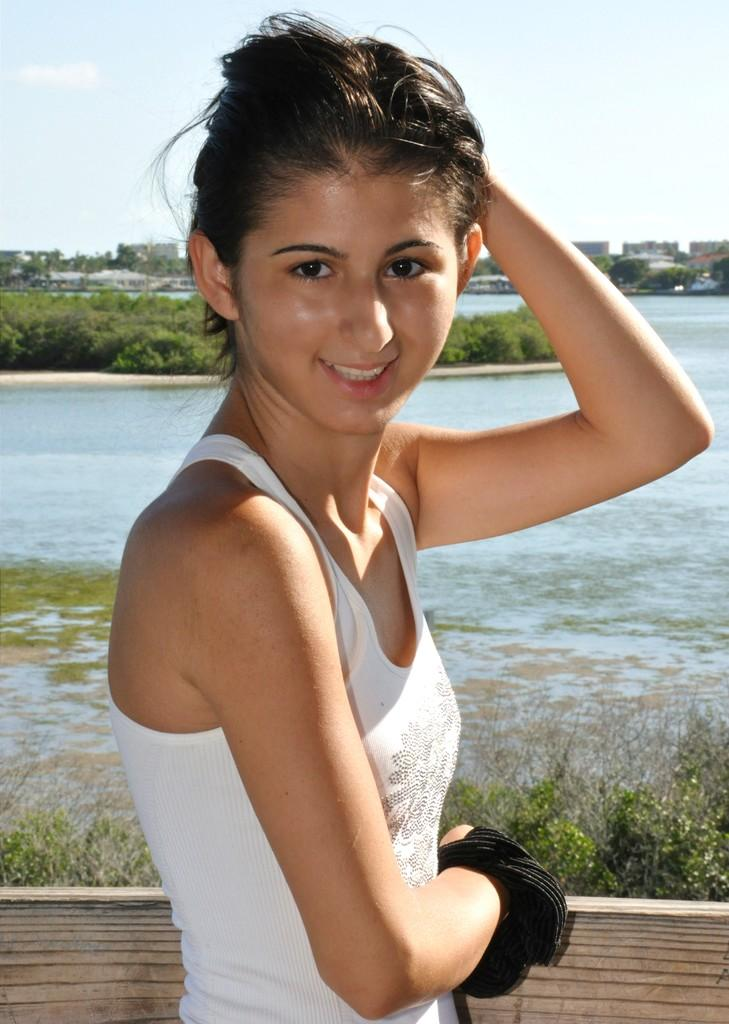Who is present in the image? There is a lady in the image. What is the lady wearing? The lady is wearing a white T-shirt. What can be seen in the background of the image? There is a lake, trees, and the sky visible in the background of the image. Where is the playground located in the image? There is no playground present in the image. What is the lady using to push the trees in the background? The lady is not pushing the trees in the background, and there is no hose present in the image. 